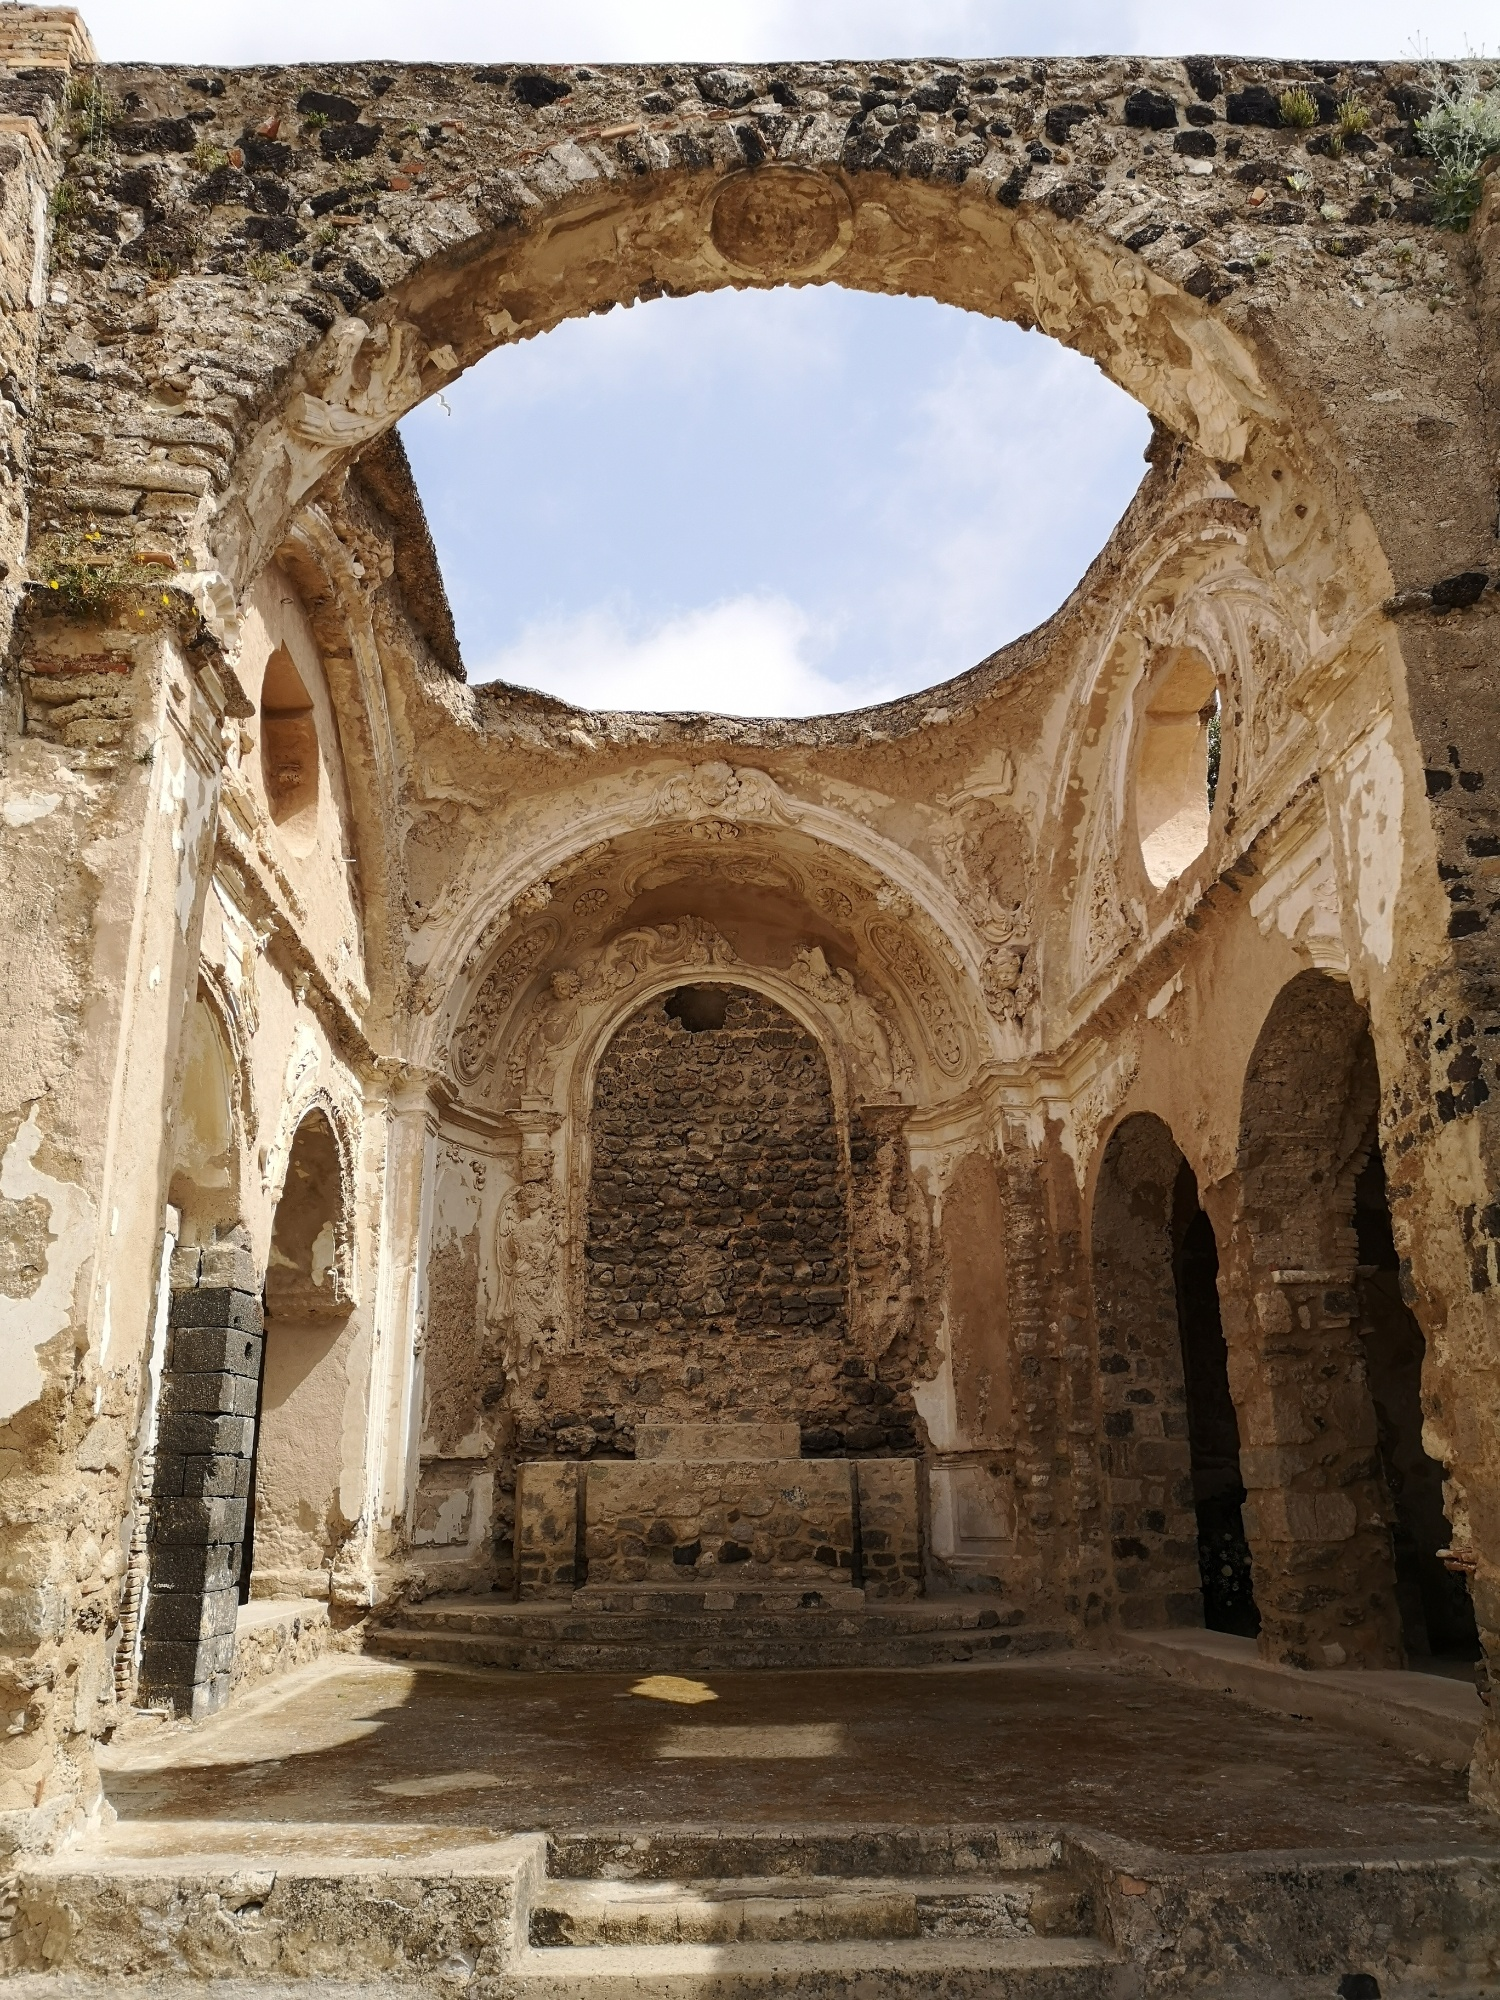Can you describe the main features of this image for me? The image showcases the interior of what appears to be an ancient church or cathedral in ruins. The building's structure, crafted from time-worn stone, rises prominently against a bright blue sky. Noteworthy are the remaining stone walls that display intricate carvings and designs, hinting at the building's historic grandeur. As we observe from a ground-level view, our eyes are naturally drawn upwards toward the impressively large arches and partially intact domes. These arches, embellished with elaborate carvings, beautifully frame the sky, creating a powerful visual contrast between the deteriorating stonework and the vibrant sky above. Sunlight streams through these openings, casting long, dramatic shadows on the stone floor and emphasizing the texture of the aged walls. Despite its decrepit state, the structure maintains a sense of majesty and awe, symbolizing the elegance of a bygone era. The scene is captured in daylight, with the sunshine accentuating the detailed carvings and the rough stone surface, bringing them to life. There's a clear absence of text or human figures, allowing the architecture to dominate the scene. The arrangement suggests the photographer was inside the structure, looking upward towards the arches and domes. Modern elements are missing from the image, further enhancing its timeless and historical atmosphere. 